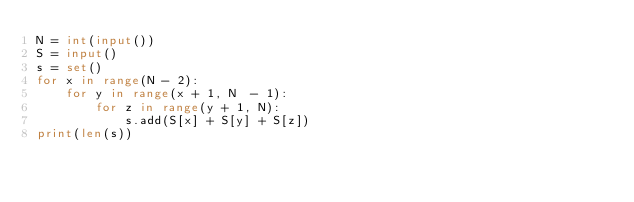Convert code to text. <code><loc_0><loc_0><loc_500><loc_500><_Python_>N = int(input())
S = input()
s = set()
for x in range(N - 2):
    for y in range(x + 1, N  - 1):
        for z in range(y + 1, N):
            s.add(S[x] + S[y] + S[z])
print(len(s))</code> 